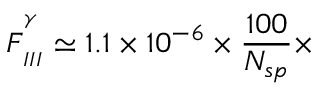Convert formula to latex. <formula><loc_0><loc_0><loc_500><loc_500>F _ { _ { I I I } } ^ { ^ { ^ { \gamma } } } \simeq 1 . 1 \times 1 0 ^ { - 6 } \times \frac { 1 0 0 } { N _ { s p } } \times</formula> 